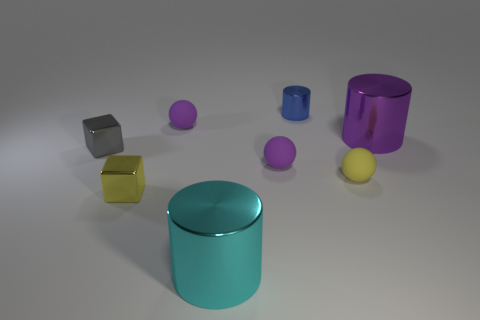Add 1 blocks. How many objects exist? 9 Subtract all cylinders. How many objects are left? 5 Subtract all purple objects. Subtract all gray metallic cubes. How many objects are left? 4 Add 7 metallic cylinders. How many metallic cylinders are left? 10 Add 5 purple matte things. How many purple matte things exist? 7 Subtract 0 gray cylinders. How many objects are left? 8 